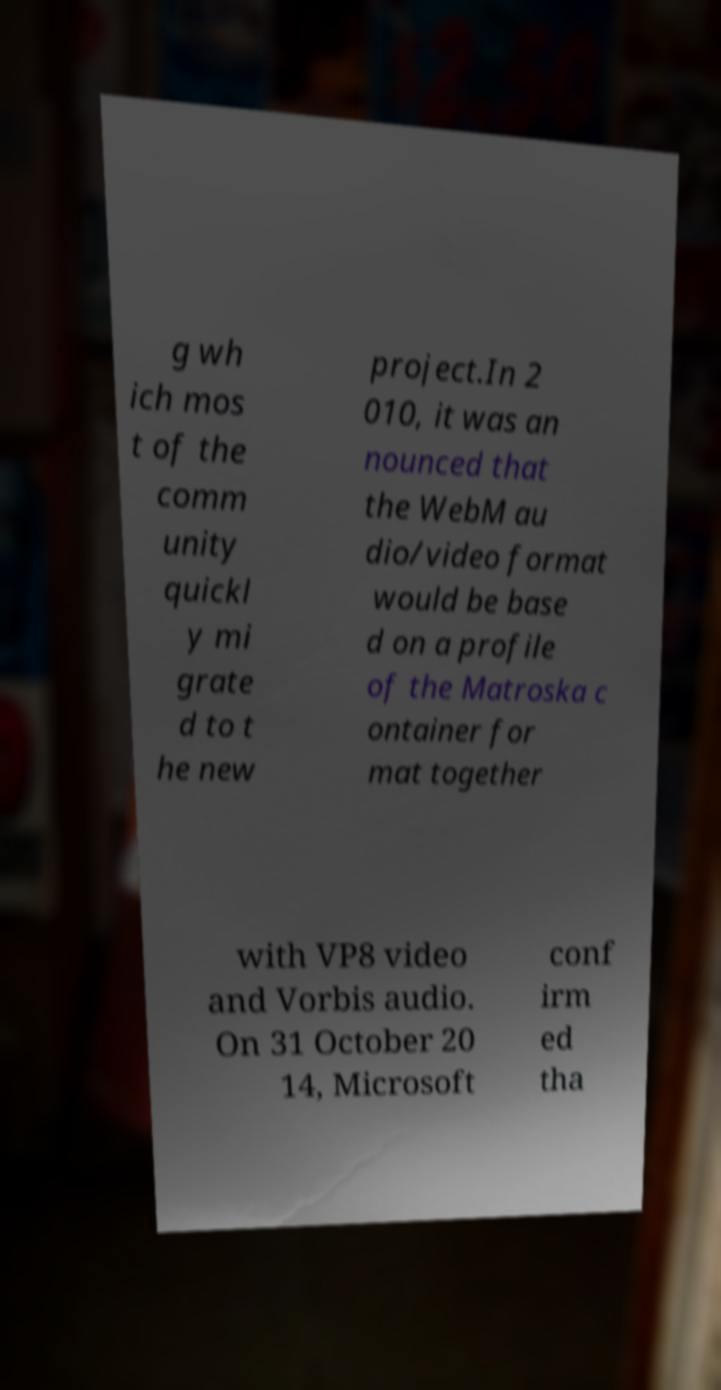Please identify and transcribe the text found in this image. g wh ich mos t of the comm unity quickl y mi grate d to t he new project.In 2 010, it was an nounced that the WebM au dio/video format would be base d on a profile of the Matroska c ontainer for mat together with VP8 video and Vorbis audio. On 31 October 20 14, Microsoft conf irm ed tha 